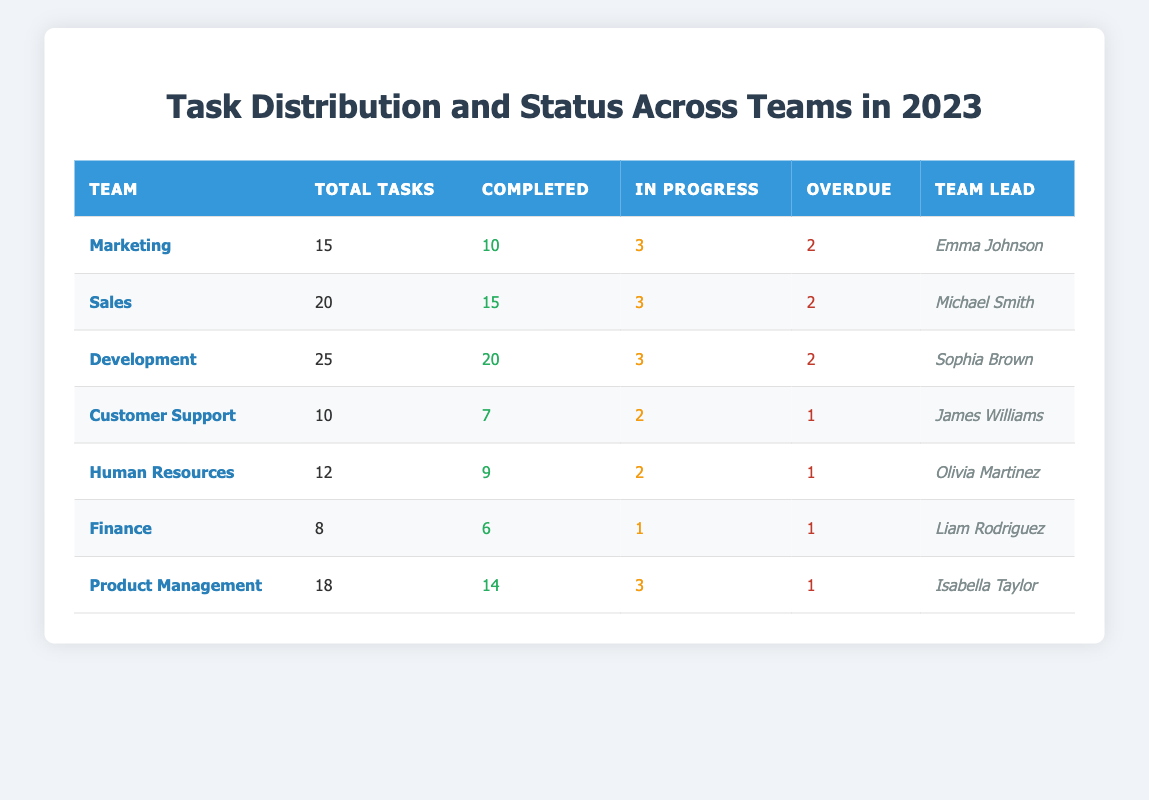What is the total number of tasks for the Marketing team? The total number of tasks for the Marketing team is specified in the table under "Total Tasks," which shows a value of 15.
Answer: 15 How many completed tasks are there for the Sales team? The table indicates the completed tasks for the Sales team in the "Completed" column as 15.
Answer: 15 Which team has the highest number of overdue tasks? By comparing the "Overdue" column, Development, Sales, and Marketing each have 2 overdue tasks, but among them, Customer Support has the lowest total tasks with only 1 overdue, making Customer Support the team with the highest percentage of overdue tasks.
Answer: Customer Support What is the average number of tasks for all teams? To find the average, sum the total tasks (15 + 20 + 25 + 10 + 12 + 8 + 18 = 108) and divide by the number of teams (7). The average is 108 / 7 = 15.43.
Answer: 15.43 Is the number of tasks completed greater than the number of in-progress tasks for the Finance team? The completed tasks for the Finance team are 6, while the in-progress tasks are 1. Since 6 > 1, the statement is true.
Answer: Yes How many teams have completed more than 10 tasks? The teams that have completed more than 10 tasks are Marketing, Sales, Development, and Product Management. That's a total of 4 teams.
Answer: 4 What is the difference in total tasks between the Development team and the Marketing team? The Development team has 25 total tasks and the Marketing team has 15 total tasks. The difference is 25 - 15 = 10.
Answer: 10 Which team has the lowest number of completed tasks? Looking at the "Completed" column, Customer Support has 7 completed tasks, which is the lowest when compared to other teams.
Answer: Customer Support How many tasks are in progress for all teams combined? The total number of in-progress tasks for all teams is the sum of each team's in-progress tasks (3 + 3 + 3 + 2 + 2 + 1 + 3 = 17).
Answer: 17 Is it true that the Human Resources team has more completed tasks than the Finance team? The Human Resources team has 9 completed tasks while the Finance team has 6. Since 9 > 6, the statement is true.
Answer: Yes Which team has the highest ratio of completed tasks to total tasks? To find the ratio, calculate for each team: Marketing (10/15), Sales (15/20), Development (20/25), Customer Support (7/10), Human Resources (9/12), Finance (6/8), Product Management (14/18). Marketing has the highest ratio, 10/15 = 0.67.
Answer: Marketing 